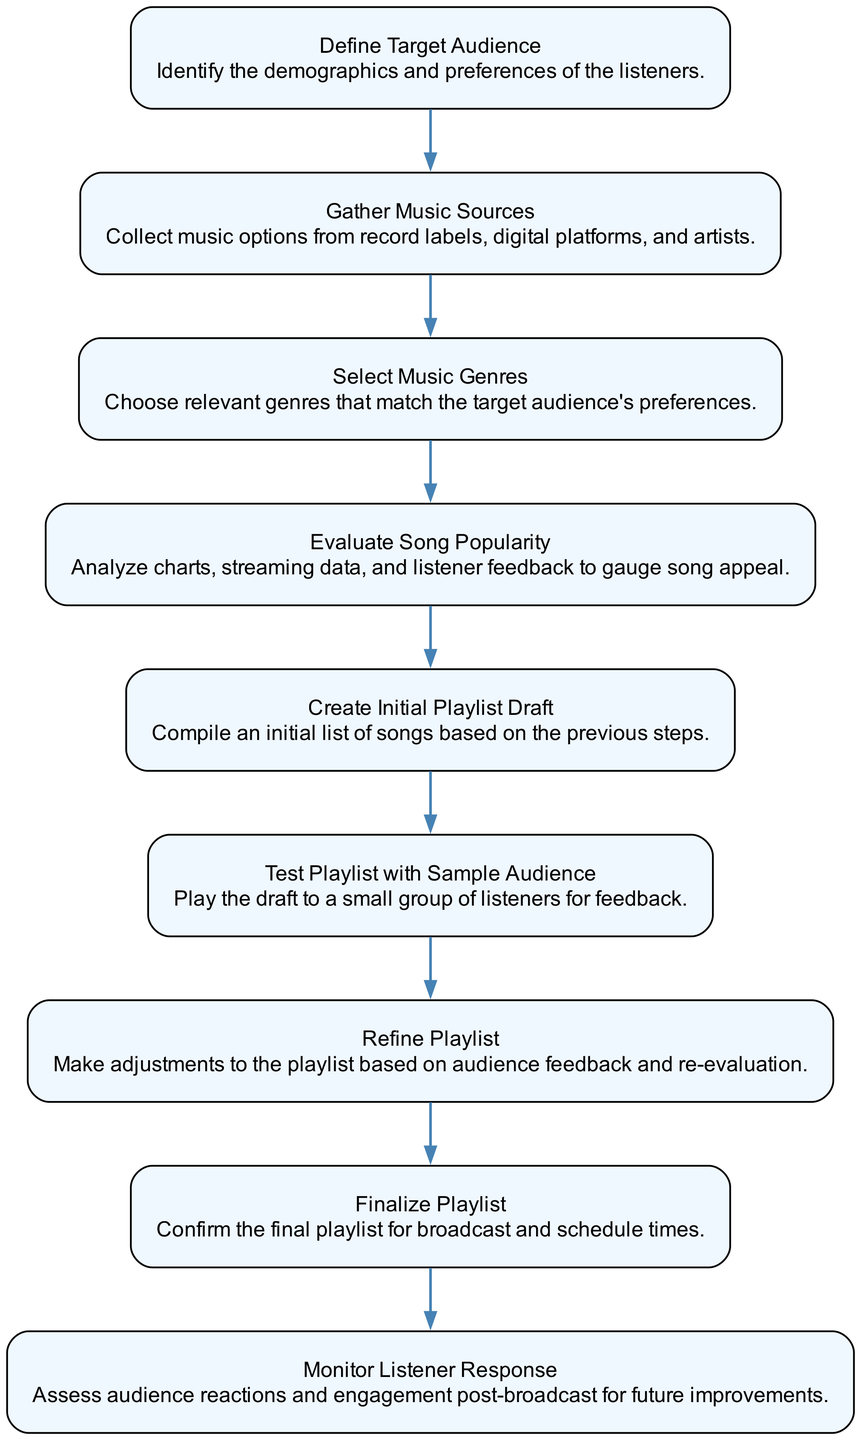What is the first step in the music playlist creation process? The first step is "Define Target Audience". It is the first element in the flow chart that lays the foundation for the subsequent steps.
Answer: Define Target Audience How many total steps are there in the process? There are nine steps in total as indicated by the nine different elements in the flow chart.
Answer: Nine What follows "Gather Music Sources"? After "Gather Music Sources", the next step is "Select Music Genres", indicating a sequential flow from one step to the next.
Answer: Select Music Genres Which step involves assessing audience reactions? The step that involves assessing audience reactions is "Monitor Listener Response", which occurs at the end of the diagram’s flow to evaluate the effectiveness of the playlist.
Answer: Monitor Listener Response What is the relationship between "Test Playlist with Sample Audience" and "Refine Playlist"? "Test Playlist with Sample Audience" leads directly to "Refine Playlist", as the feedback received from the test audience should inform adjustments to the playlist.
Answer: Leads to What is the name of the step that compiles an initial list of songs? The step that compiles an initial list of songs is called "Create Initial Playlist Draft". This is a crucial step before any testing or refining occurs.
Answer: Create Initial Playlist Draft What is the last step in the flow chart? The last step in the flow chart is "Monitor Listener Response", which reflects the ongoing need to evaluate the audience's engagement with the playlist.
Answer: Monitor Listener Response Which step follows "Evaluate Song Popularity"? Following "Evaluate Song Popularity" is "Create Initial Playlist Draft", establishing the importance of song evaluation before drafting the playlist.
Answer: Create Initial Playlist Draft What process comes after "Finalize Playlist"? After "Finalize Playlist", the next in the process is "Monitor Listener Response", showing the continuous nature of audience engagement after finalization.
Answer: Monitor Listener Response 